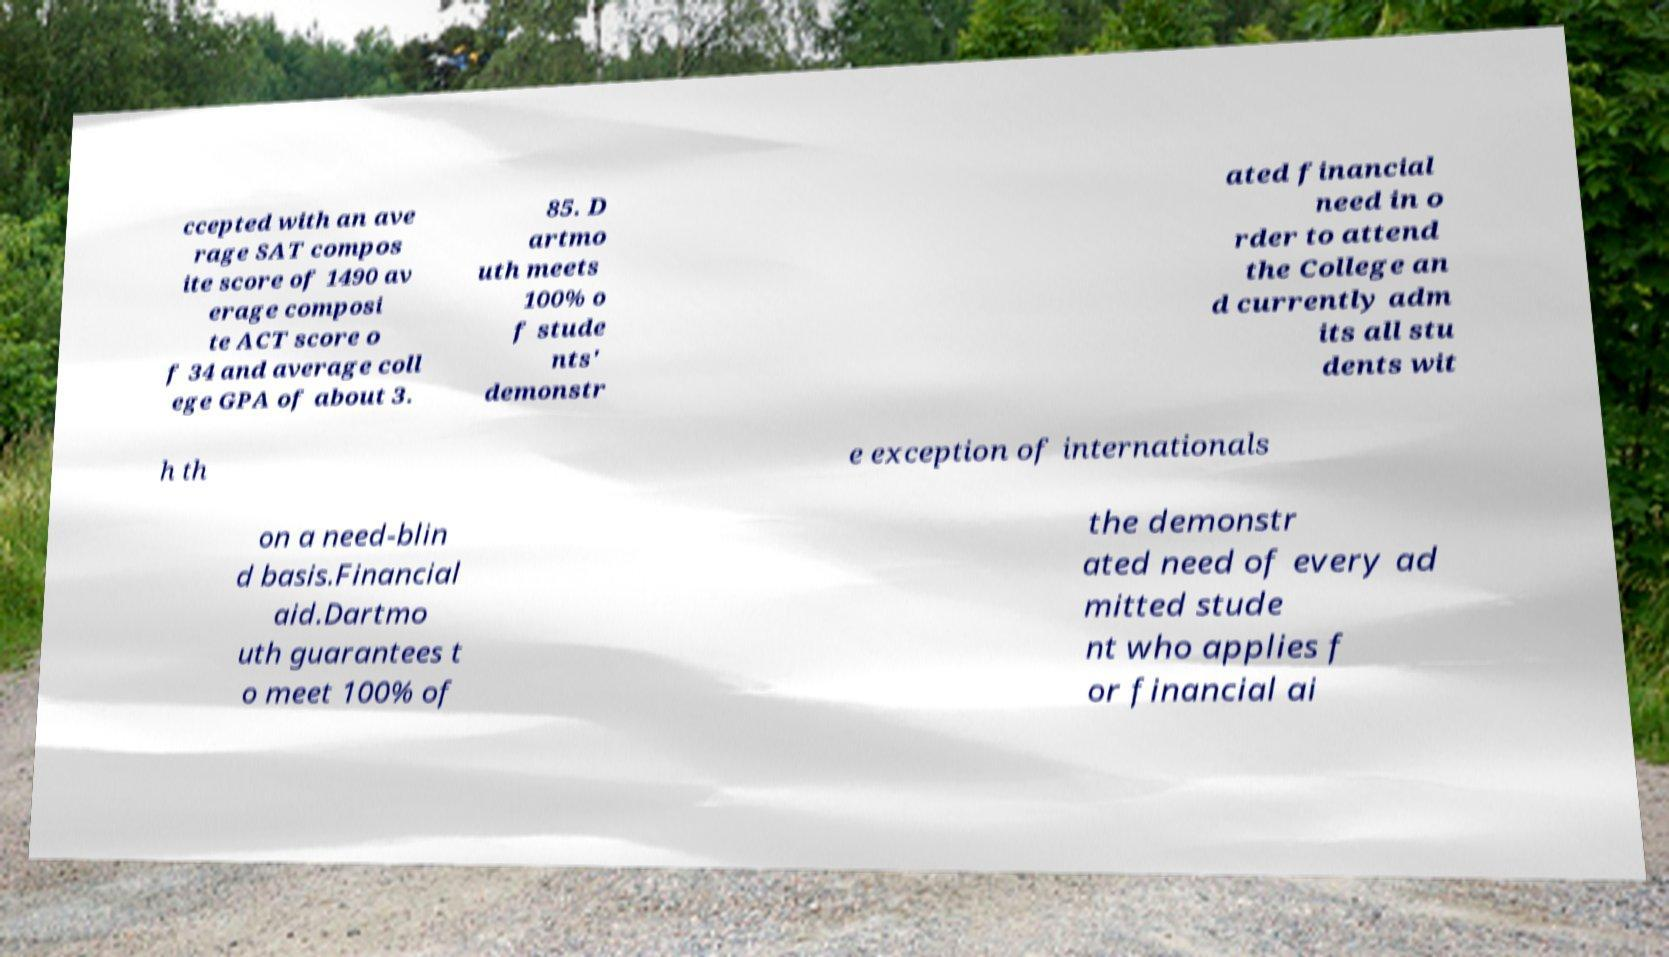Could you extract and type out the text from this image? ccepted with an ave rage SAT compos ite score of 1490 av erage composi te ACT score o f 34 and average coll ege GPA of about 3. 85. D artmo uth meets 100% o f stude nts' demonstr ated financial need in o rder to attend the College an d currently adm its all stu dents wit h th e exception of internationals on a need-blin d basis.Financial aid.Dartmo uth guarantees t o meet 100% of the demonstr ated need of every ad mitted stude nt who applies f or financial ai 